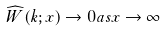Convert formula to latex. <formula><loc_0><loc_0><loc_500><loc_500>\widehat { W } ( k ; x ) \to 0 a s x \to \infty</formula> 